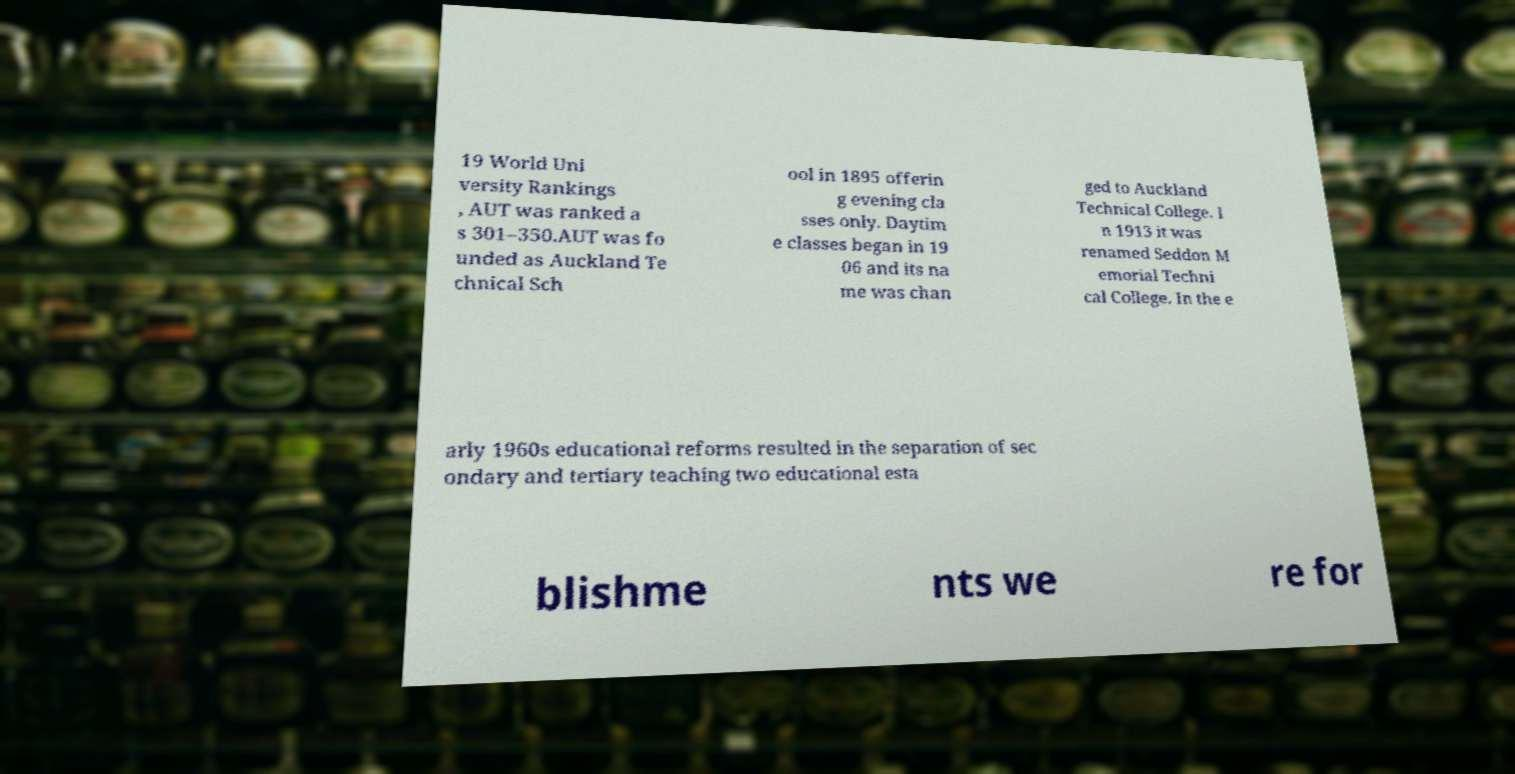What messages or text are displayed in this image? I need them in a readable, typed format. 19 World Uni versity Rankings , AUT was ranked a s 301–350.AUT was fo unded as Auckland Te chnical Sch ool in 1895 offerin g evening cla sses only. Daytim e classes began in 19 06 and its na me was chan ged to Auckland Technical College. I n 1913 it was renamed Seddon M emorial Techni cal College. In the e arly 1960s educational reforms resulted in the separation of sec ondary and tertiary teaching two educational esta blishme nts we re for 